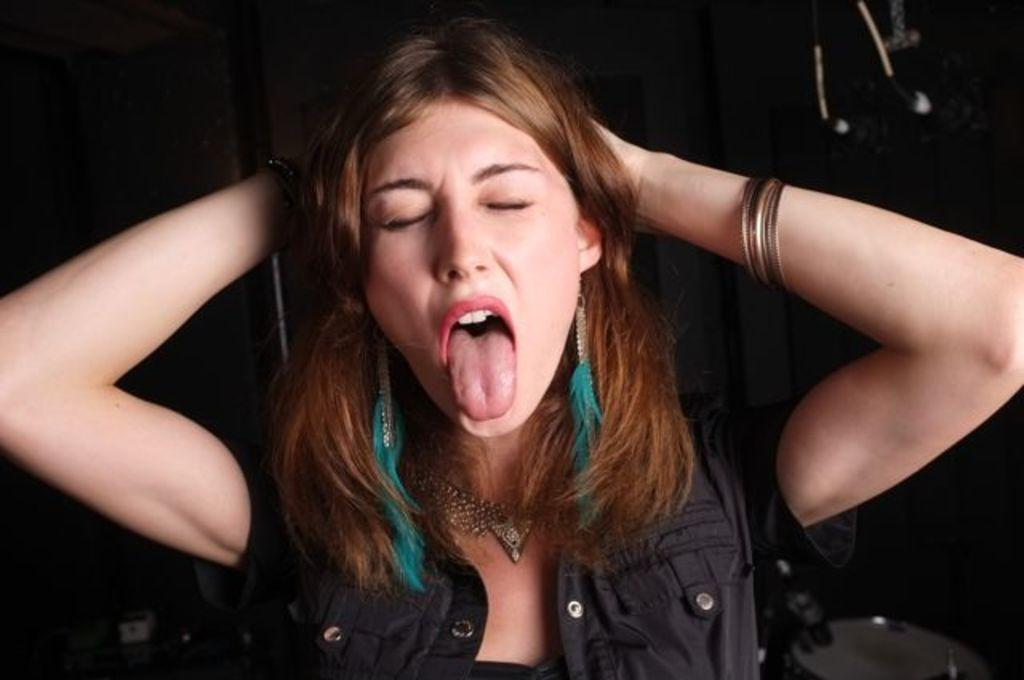Who is the main subject in the image? There is a woman in the image. What is the woman wearing in the image? The woman is wearing a black jacket and bangles. Can you describe the background of the image? The background of the image is dark. How much money is the woman holding in the image? There is no indication of the woman holding money in the image. What type of linen is draped over the furniture in the image? There is no furniture or linen present in the image. 